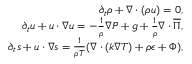<formula> <loc_0><loc_0><loc_500><loc_500>\begin{array} { r } { \partial _ { t } \rho + { \nabla } \cdot ( \rho { \boldsymbol } { u } ) = 0 , } \\ { \partial _ { t } { \boldsymbol } { u } + { \boldsymbol } { u } \cdot { \nabla } { \boldsymbol } { u } = - \frac { 1 } { \rho } { \nabla } P + { \boldsymbol } { g } + \frac { 1 } { \rho } { \nabla } \cdot { \boldsymbol } { \overline { \Pi } } , } \\ { \partial _ { t } s + { \boldsymbol } { u } \cdot { \nabla } s = \frac { 1 } { \rho T } ( { \nabla } \cdot ( k { \nabla } T ) + \rho \epsilon + \Phi ) , } \end{array}</formula> 